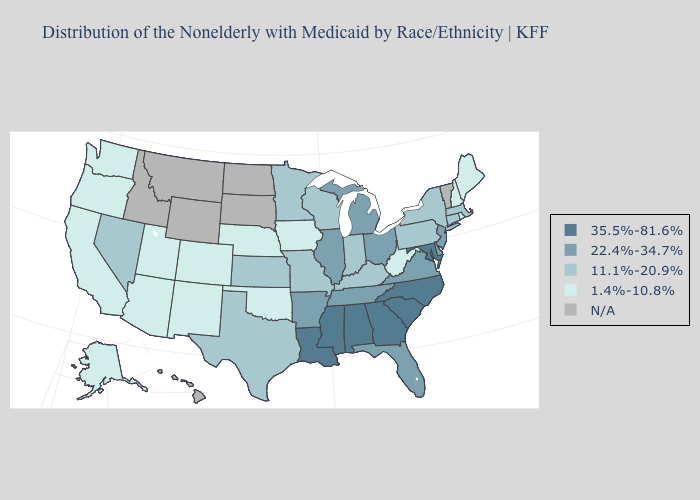Among the states that border New York , does New Jersey have the highest value?
Concise answer only. Yes. Among the states that border Pennsylvania , does New York have the highest value?
Keep it brief. No. Does Illinois have the highest value in the USA?
Answer briefly. No. Does Maryland have the highest value in the South?
Answer briefly. Yes. What is the value of Florida?
Write a very short answer. 22.4%-34.7%. Does Alabama have the highest value in the USA?
Concise answer only. Yes. What is the value of Wisconsin?
Concise answer only. 11.1%-20.9%. Does Oklahoma have the highest value in the USA?
Short answer required. No. What is the value of Missouri?
Be succinct. 11.1%-20.9%. Which states hav the highest value in the West?
Write a very short answer. Nevada. What is the value of North Dakota?
Give a very brief answer. N/A. Name the states that have a value in the range N/A?
Give a very brief answer. Hawaii, Idaho, Montana, North Dakota, South Dakota, Vermont, Wyoming. Among the states that border Connecticut , does New York have the lowest value?
Quick response, please. No. Among the states that border Indiana , which have the highest value?
Write a very short answer. Illinois, Michigan, Ohio. 